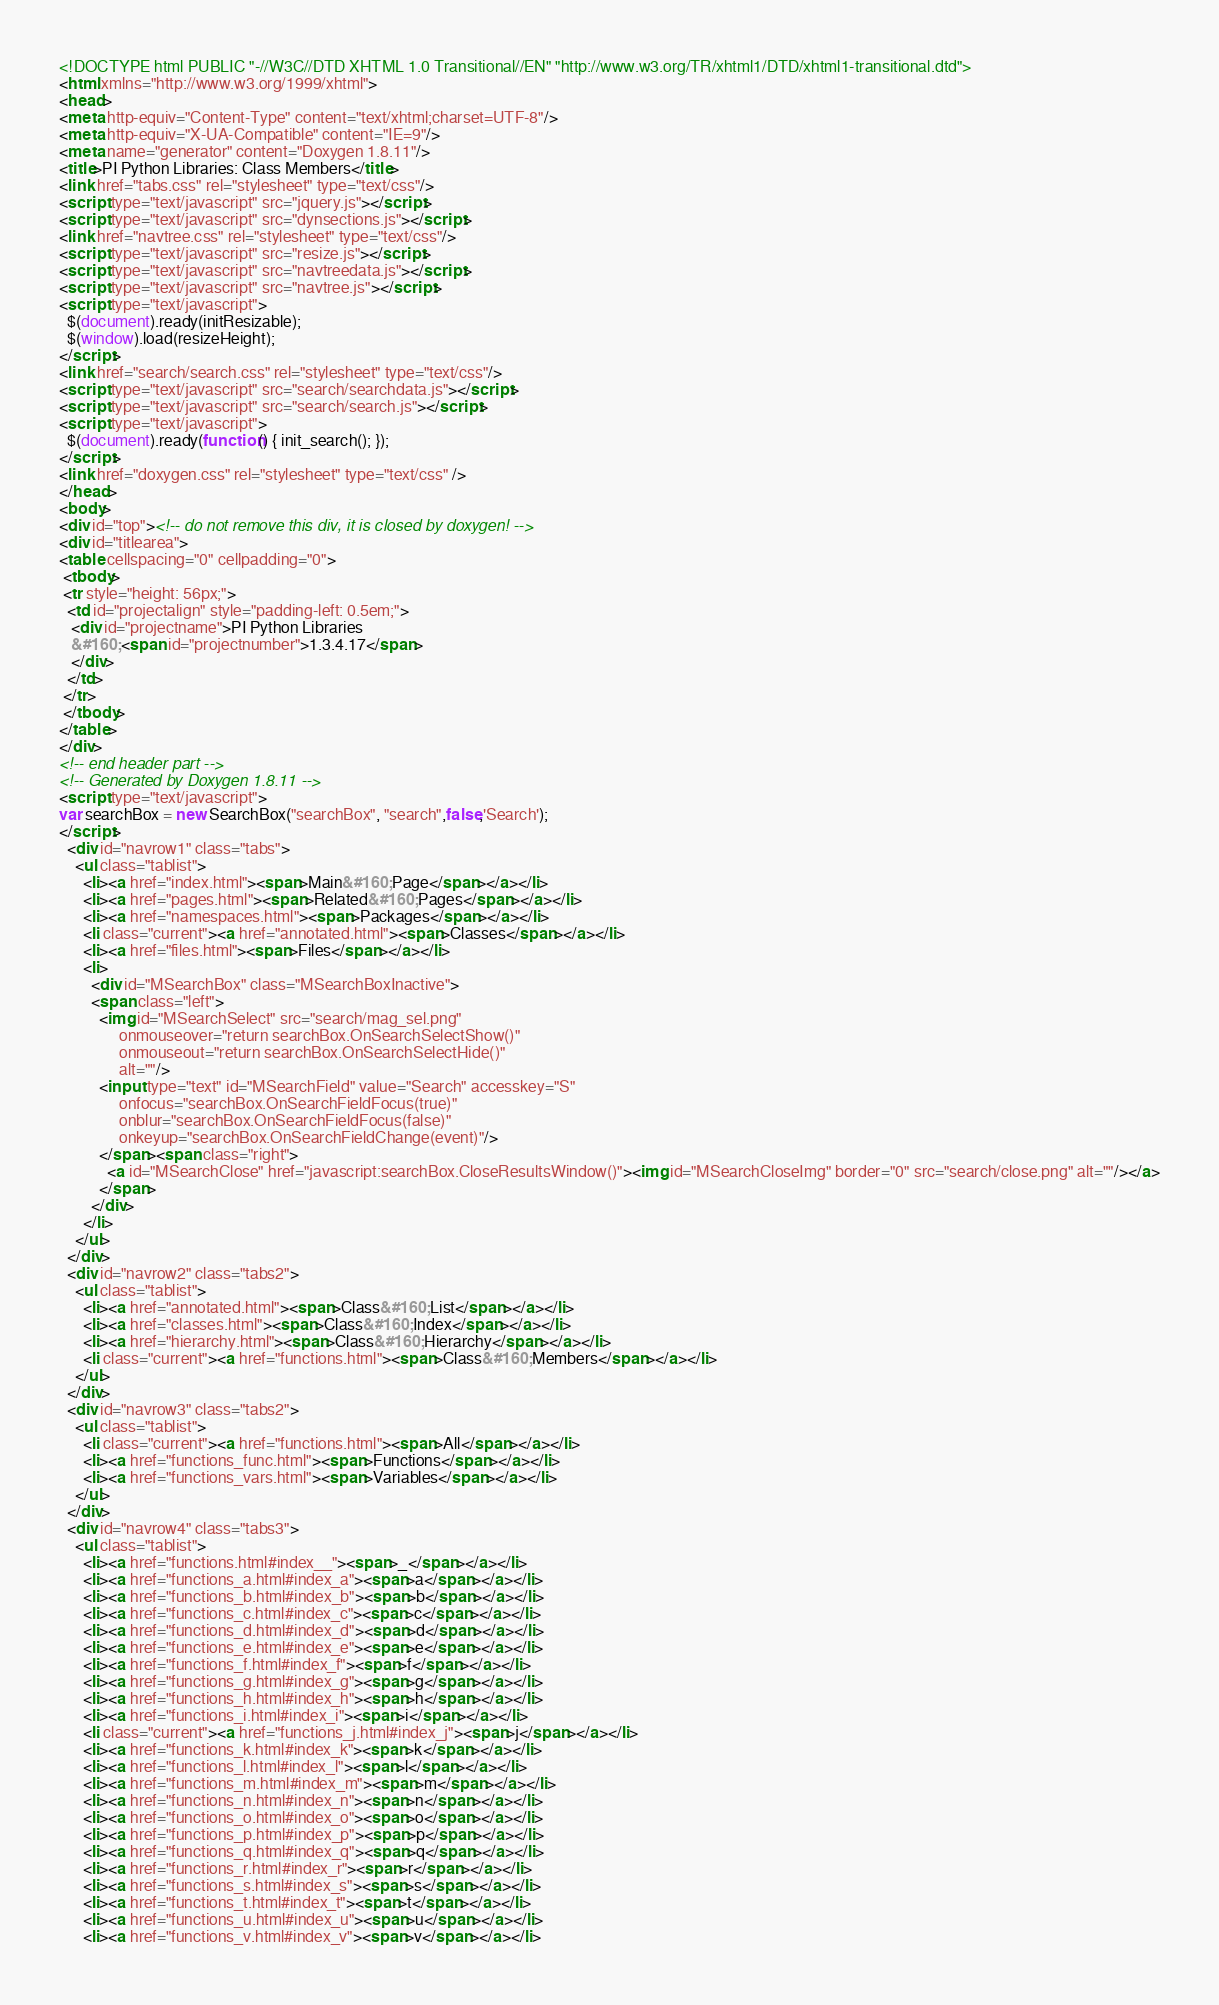<code> <loc_0><loc_0><loc_500><loc_500><_HTML_><!DOCTYPE html PUBLIC "-//W3C//DTD XHTML 1.0 Transitional//EN" "http://www.w3.org/TR/xhtml1/DTD/xhtml1-transitional.dtd">
<html xmlns="http://www.w3.org/1999/xhtml">
<head>
<meta http-equiv="Content-Type" content="text/xhtml;charset=UTF-8"/>
<meta http-equiv="X-UA-Compatible" content="IE=9"/>
<meta name="generator" content="Doxygen 1.8.11"/>
<title>PI Python Libraries: Class Members</title>
<link href="tabs.css" rel="stylesheet" type="text/css"/>
<script type="text/javascript" src="jquery.js"></script>
<script type="text/javascript" src="dynsections.js"></script>
<link href="navtree.css" rel="stylesheet" type="text/css"/>
<script type="text/javascript" src="resize.js"></script>
<script type="text/javascript" src="navtreedata.js"></script>
<script type="text/javascript" src="navtree.js"></script>
<script type="text/javascript">
  $(document).ready(initResizable);
  $(window).load(resizeHeight);
</script>
<link href="search/search.css" rel="stylesheet" type="text/css"/>
<script type="text/javascript" src="search/searchdata.js"></script>
<script type="text/javascript" src="search/search.js"></script>
<script type="text/javascript">
  $(document).ready(function() { init_search(); });
</script>
<link href="doxygen.css" rel="stylesheet" type="text/css" />
</head>
<body>
<div id="top"><!-- do not remove this div, it is closed by doxygen! -->
<div id="titlearea">
<table cellspacing="0" cellpadding="0">
 <tbody>
 <tr style="height: 56px;">
  <td id="projectalign" style="padding-left: 0.5em;">
   <div id="projectname">PI Python Libraries
   &#160;<span id="projectnumber">1.3.4.17</span>
   </div>
  </td>
 </tr>
 </tbody>
</table>
</div>
<!-- end header part -->
<!-- Generated by Doxygen 1.8.11 -->
<script type="text/javascript">
var searchBox = new SearchBox("searchBox", "search",false,'Search');
</script>
  <div id="navrow1" class="tabs">
    <ul class="tablist">
      <li><a href="index.html"><span>Main&#160;Page</span></a></li>
      <li><a href="pages.html"><span>Related&#160;Pages</span></a></li>
      <li><a href="namespaces.html"><span>Packages</span></a></li>
      <li class="current"><a href="annotated.html"><span>Classes</span></a></li>
      <li><a href="files.html"><span>Files</span></a></li>
      <li>
        <div id="MSearchBox" class="MSearchBoxInactive">
        <span class="left">
          <img id="MSearchSelect" src="search/mag_sel.png"
               onmouseover="return searchBox.OnSearchSelectShow()"
               onmouseout="return searchBox.OnSearchSelectHide()"
               alt=""/>
          <input type="text" id="MSearchField" value="Search" accesskey="S"
               onfocus="searchBox.OnSearchFieldFocus(true)" 
               onblur="searchBox.OnSearchFieldFocus(false)" 
               onkeyup="searchBox.OnSearchFieldChange(event)"/>
          </span><span class="right">
            <a id="MSearchClose" href="javascript:searchBox.CloseResultsWindow()"><img id="MSearchCloseImg" border="0" src="search/close.png" alt=""/></a>
          </span>
        </div>
      </li>
    </ul>
  </div>
  <div id="navrow2" class="tabs2">
    <ul class="tablist">
      <li><a href="annotated.html"><span>Class&#160;List</span></a></li>
      <li><a href="classes.html"><span>Class&#160;Index</span></a></li>
      <li><a href="hierarchy.html"><span>Class&#160;Hierarchy</span></a></li>
      <li class="current"><a href="functions.html"><span>Class&#160;Members</span></a></li>
    </ul>
  </div>
  <div id="navrow3" class="tabs2">
    <ul class="tablist">
      <li class="current"><a href="functions.html"><span>All</span></a></li>
      <li><a href="functions_func.html"><span>Functions</span></a></li>
      <li><a href="functions_vars.html"><span>Variables</span></a></li>
    </ul>
  </div>
  <div id="navrow4" class="tabs3">
    <ul class="tablist">
      <li><a href="functions.html#index__"><span>_</span></a></li>
      <li><a href="functions_a.html#index_a"><span>a</span></a></li>
      <li><a href="functions_b.html#index_b"><span>b</span></a></li>
      <li><a href="functions_c.html#index_c"><span>c</span></a></li>
      <li><a href="functions_d.html#index_d"><span>d</span></a></li>
      <li><a href="functions_e.html#index_e"><span>e</span></a></li>
      <li><a href="functions_f.html#index_f"><span>f</span></a></li>
      <li><a href="functions_g.html#index_g"><span>g</span></a></li>
      <li><a href="functions_h.html#index_h"><span>h</span></a></li>
      <li><a href="functions_i.html#index_i"><span>i</span></a></li>
      <li class="current"><a href="functions_j.html#index_j"><span>j</span></a></li>
      <li><a href="functions_k.html#index_k"><span>k</span></a></li>
      <li><a href="functions_l.html#index_l"><span>l</span></a></li>
      <li><a href="functions_m.html#index_m"><span>m</span></a></li>
      <li><a href="functions_n.html#index_n"><span>n</span></a></li>
      <li><a href="functions_o.html#index_o"><span>o</span></a></li>
      <li><a href="functions_p.html#index_p"><span>p</span></a></li>
      <li><a href="functions_q.html#index_q"><span>q</span></a></li>
      <li><a href="functions_r.html#index_r"><span>r</span></a></li>
      <li><a href="functions_s.html#index_s"><span>s</span></a></li>
      <li><a href="functions_t.html#index_t"><span>t</span></a></li>
      <li><a href="functions_u.html#index_u"><span>u</span></a></li>
      <li><a href="functions_v.html#index_v"><span>v</span></a></li></code> 